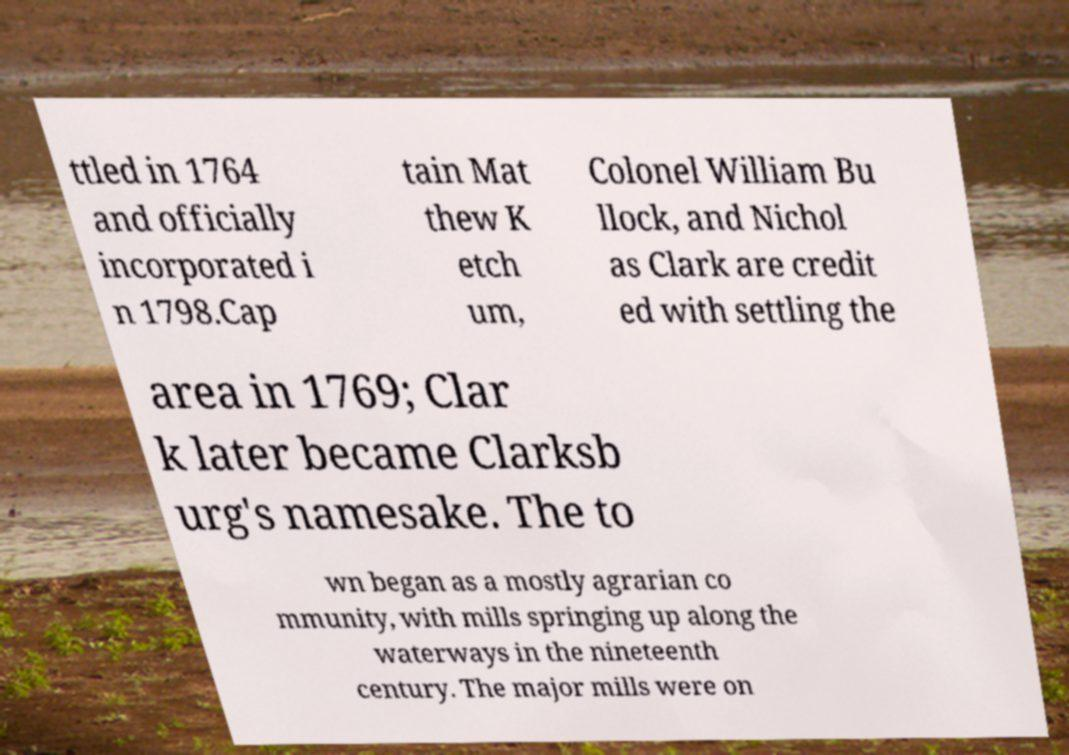Can you accurately transcribe the text from the provided image for me? ttled in 1764 and officially incorporated i n 1798.Cap tain Mat thew K etch um, Colonel William Bu llock, and Nichol as Clark are credit ed with settling the area in 1769; Clar k later became Clarksb urg's namesake. The to wn began as a mostly agrarian co mmunity, with mills springing up along the waterways in the nineteenth century. The major mills were on 